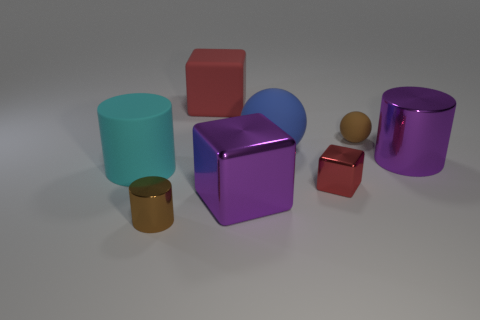Subtract all blue cylinders. How many red cubes are left? 2 Subtract all big purple metal cylinders. How many cylinders are left? 2 Add 1 blue rubber things. How many objects exist? 9 Subtract all green cylinders. Subtract all gray cubes. How many cylinders are left? 3 Add 3 big yellow metal blocks. How many big yellow metal blocks exist? 3 Subtract 0 gray cylinders. How many objects are left? 8 Subtract all cylinders. How many objects are left? 5 Subtract all large metallic objects. Subtract all large red things. How many objects are left? 5 Add 7 brown metallic objects. How many brown metallic objects are left? 8 